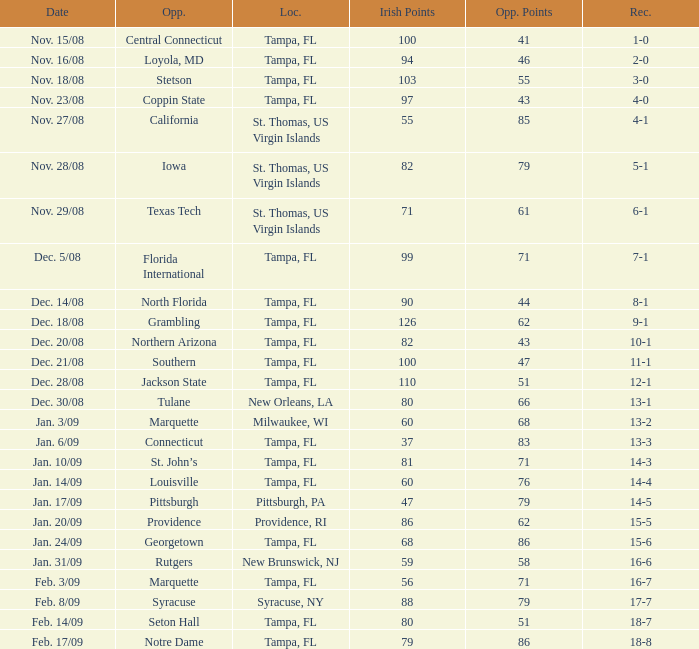What is the number of opponents where the location is syracuse, ny? 1.0. 